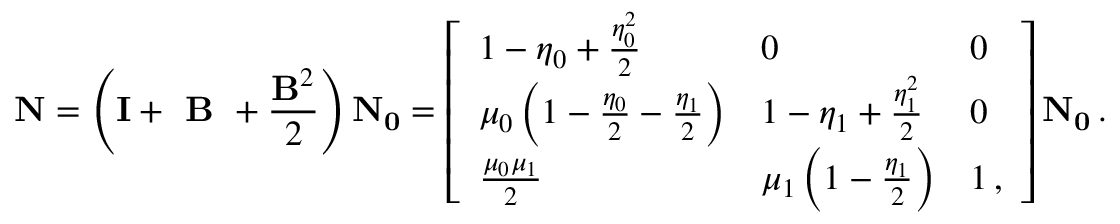<formula> <loc_0><loc_0><loc_500><loc_500>N = \left ( I + B + \frac { B ^ { 2 } } { 2 } \right ) N _ { 0 } = \left [ \begin{array} { l l l } { 1 - \eta _ { 0 } + \frac { \eta _ { 0 } ^ { 2 } } { 2 } } & { 0 } & { 0 } \\ { \mu _ { 0 } \left ( 1 - \frac { \eta _ { 0 } } { 2 } - \frac { \eta _ { 1 } } { 2 } \right ) } & { 1 - \eta _ { 1 } + \frac { \eta _ { 1 } ^ { 2 } } { 2 } } & { 0 } \\ { \frac { \mu _ { 0 } \mu _ { 1 } } { 2 } } & { \mu _ { 1 } \left ( 1 - \frac { \eta _ { 1 } } { 2 } \right ) } & { 1 \, , } \end{array} \right ] N _ { 0 } \, .</formula> 